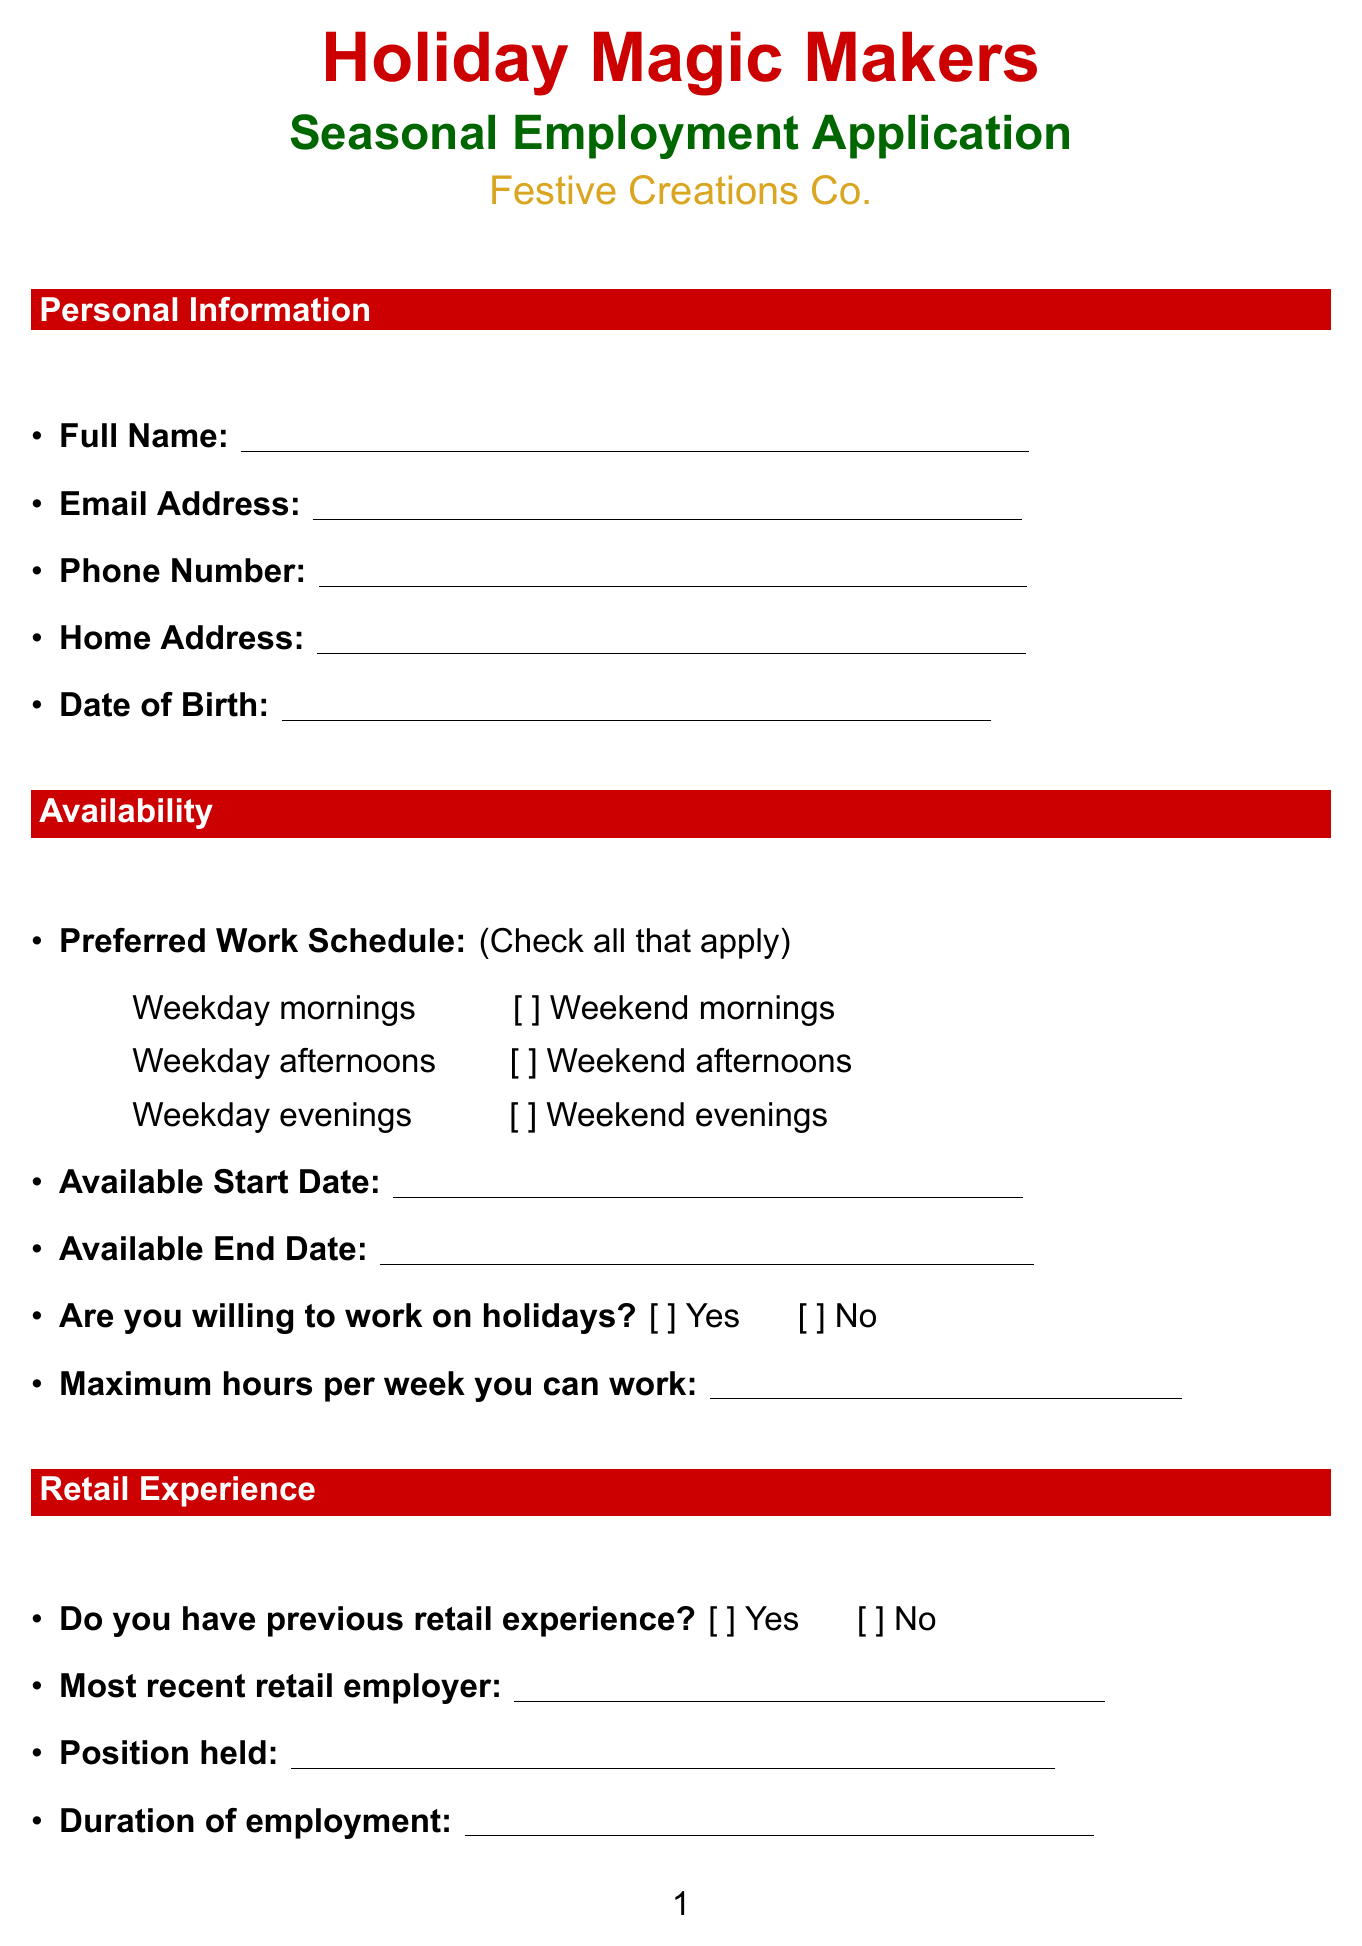What is the title of the application form? The title of the application form is clearly stated at the top of the document.
Answer: Holiday Magic Makers Seasonal Employment Application What company is this application for? The company name is provided in the document, which is essential for applicants.
Answer: Festive Creations Co What is the maximum number of hours a candidate can work per week? The document specifies a requirement for maximum work hours which candidates need to fill out.
Answer: 40 Are candidates required to provide their email address? The section for personal information indicates the required fields clearly.
Answer: Yes What are the options available for preferred work schedule? The options for preferred work schedule are listed as choices in the document.
Answer: Weekday mornings, Weekday afternoons, Weekday evenings, Weekend mornings, Weekend afternoons, Weekend evenings Is previous retail experience mandatory for applicants? The section asking about retail experience indicates whether it's required or not for the application.
Answer: No What is necessary to certify in the legal information section? The legal information section includes a certification statement that must be acknowledged by the applicant.
Answer: All information provided is true and complete Do applicants need to detail their most recent retail employer? Applicants are asked for their most recent retail employer, which is an optional field in the document.
Answer: No Are candidates asked if they can work on holidays? The document includes a specific question regarding holiday work, which is important for seasonal employment.
Answer: Yes What does the applicant need to complete at the bottom of the form? The bottom of the form contains a legal eligibility question, which is crucial for employment.
Answer: Eligibility to work in the United States 